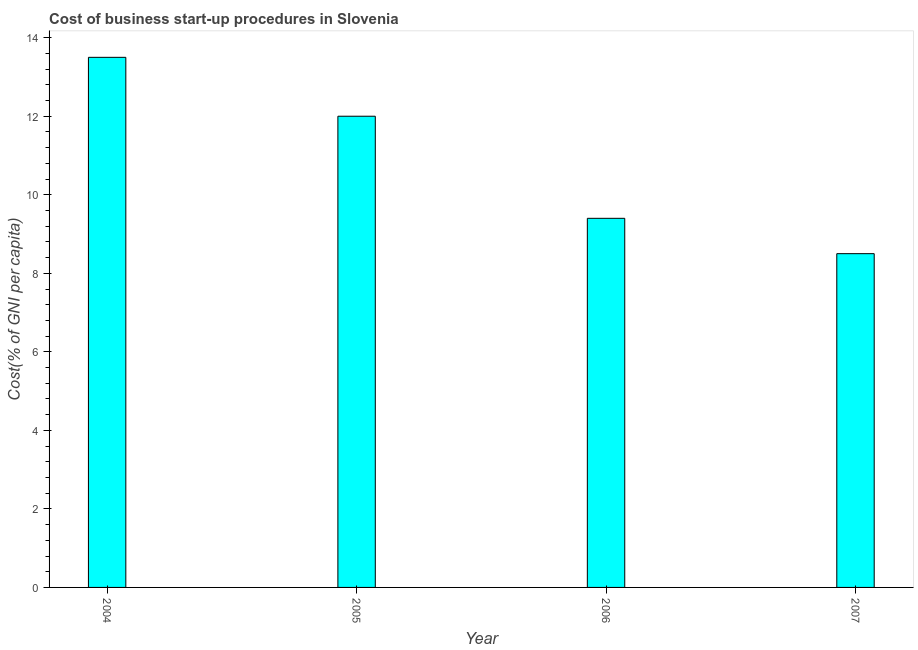What is the title of the graph?
Offer a very short reply. Cost of business start-up procedures in Slovenia. What is the label or title of the Y-axis?
Give a very brief answer. Cost(% of GNI per capita). Across all years, what is the minimum cost of business startup procedures?
Ensure brevity in your answer.  8.5. What is the sum of the cost of business startup procedures?
Offer a very short reply. 43.4. What is the difference between the cost of business startup procedures in 2004 and 2007?
Ensure brevity in your answer.  5. What is the average cost of business startup procedures per year?
Offer a terse response. 10.85. In how many years, is the cost of business startup procedures greater than 4.4 %?
Provide a short and direct response. 4. What is the ratio of the cost of business startup procedures in 2004 to that in 2006?
Offer a terse response. 1.44. Is the difference between the cost of business startup procedures in 2004 and 2006 greater than the difference between any two years?
Offer a terse response. No. Is the sum of the cost of business startup procedures in 2005 and 2007 greater than the maximum cost of business startup procedures across all years?
Provide a succinct answer. Yes. Are all the bars in the graph horizontal?
Make the answer very short. No. Are the values on the major ticks of Y-axis written in scientific E-notation?
Offer a very short reply. No. What is the Cost(% of GNI per capita) in 2004?
Your response must be concise. 13.5. What is the Cost(% of GNI per capita) in 2005?
Keep it short and to the point. 12. What is the Cost(% of GNI per capita) of 2007?
Keep it short and to the point. 8.5. What is the difference between the Cost(% of GNI per capita) in 2004 and 2005?
Give a very brief answer. 1.5. What is the difference between the Cost(% of GNI per capita) in 2004 and 2007?
Offer a terse response. 5. What is the difference between the Cost(% of GNI per capita) in 2005 and 2006?
Provide a succinct answer. 2.6. What is the difference between the Cost(% of GNI per capita) in 2006 and 2007?
Give a very brief answer. 0.9. What is the ratio of the Cost(% of GNI per capita) in 2004 to that in 2005?
Make the answer very short. 1.12. What is the ratio of the Cost(% of GNI per capita) in 2004 to that in 2006?
Offer a very short reply. 1.44. What is the ratio of the Cost(% of GNI per capita) in 2004 to that in 2007?
Offer a very short reply. 1.59. What is the ratio of the Cost(% of GNI per capita) in 2005 to that in 2006?
Keep it short and to the point. 1.28. What is the ratio of the Cost(% of GNI per capita) in 2005 to that in 2007?
Your answer should be compact. 1.41. What is the ratio of the Cost(% of GNI per capita) in 2006 to that in 2007?
Your response must be concise. 1.11. 